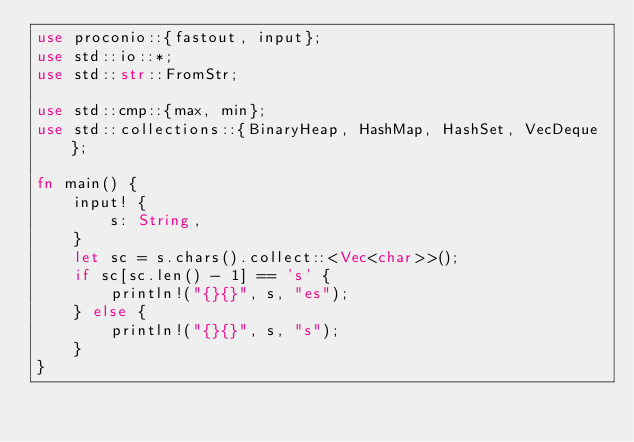<code> <loc_0><loc_0><loc_500><loc_500><_Rust_>use proconio::{fastout, input};
use std::io::*;
use std::str::FromStr;

use std::cmp::{max, min};
use std::collections::{BinaryHeap, HashMap, HashSet, VecDeque};

fn main() {
    input! {
        s: String,
    }
    let sc = s.chars().collect::<Vec<char>>();
    if sc[sc.len() - 1] == 's' {
        println!("{}{}", s, "es");
    } else {
        println!("{}{}", s, "s");
    }
}
</code> 